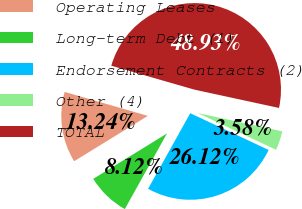Convert chart. <chart><loc_0><loc_0><loc_500><loc_500><pie_chart><fcel>Operating Leases<fcel>Long-term Debt (1)<fcel>Endorsement Contracts (2)<fcel>Other (4)<fcel>TOTAL<nl><fcel>13.24%<fcel>8.12%<fcel>26.12%<fcel>3.58%<fcel>48.93%<nl></chart> 